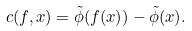<formula> <loc_0><loc_0><loc_500><loc_500>c ( f , x ) = \tilde { \phi } ( f ( x ) ) - \tilde { \phi } ( x ) .</formula> 